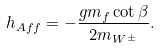Convert formula to latex. <formula><loc_0><loc_0><loc_500><loc_500>h _ { A f f } = - \frac { g m _ { f } \cot \beta } { 2 m _ { W ^ { \pm } } } .</formula> 